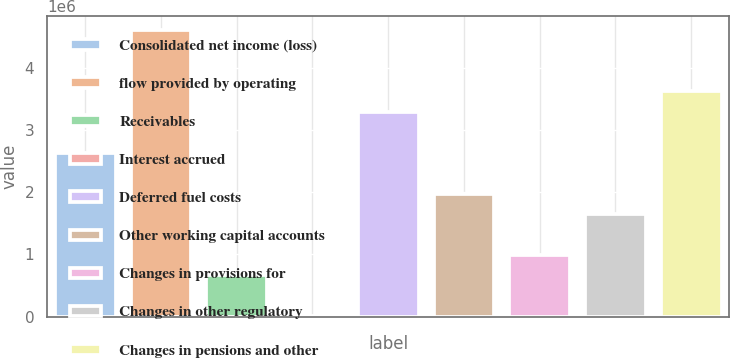<chart> <loc_0><loc_0><loc_500><loc_500><bar_chart><fcel>Consolidated net income (loss)<fcel>flow provided by operating<fcel>Receivables<fcel>Interest accrued<fcel>Deferred fuel costs<fcel>Other working capital accounts<fcel>Changes in provisions for<fcel>Changes in other regulatory<fcel>Changes in pensions and other<nl><fcel>2.63524e+06<fcel>4.60308e+06<fcel>667393<fcel>11445<fcel>3.29118e+06<fcel>1.97929e+06<fcel>995367<fcel>1.65131e+06<fcel>3.61916e+06<nl></chart> 